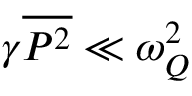<formula> <loc_0><loc_0><loc_500><loc_500>\gamma \overline { { P ^ { 2 } } } \ll \omega _ { Q } ^ { 2 }</formula> 